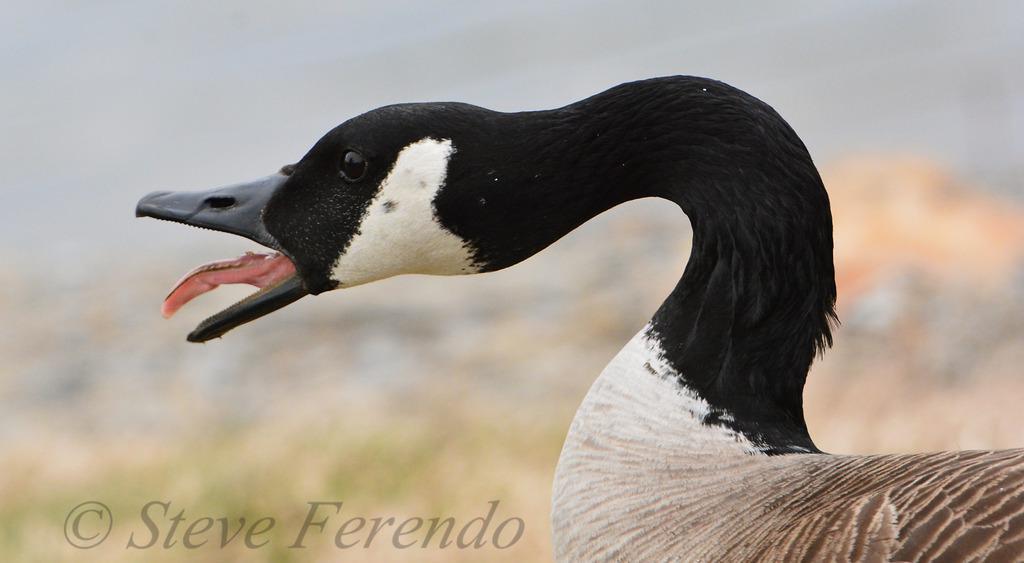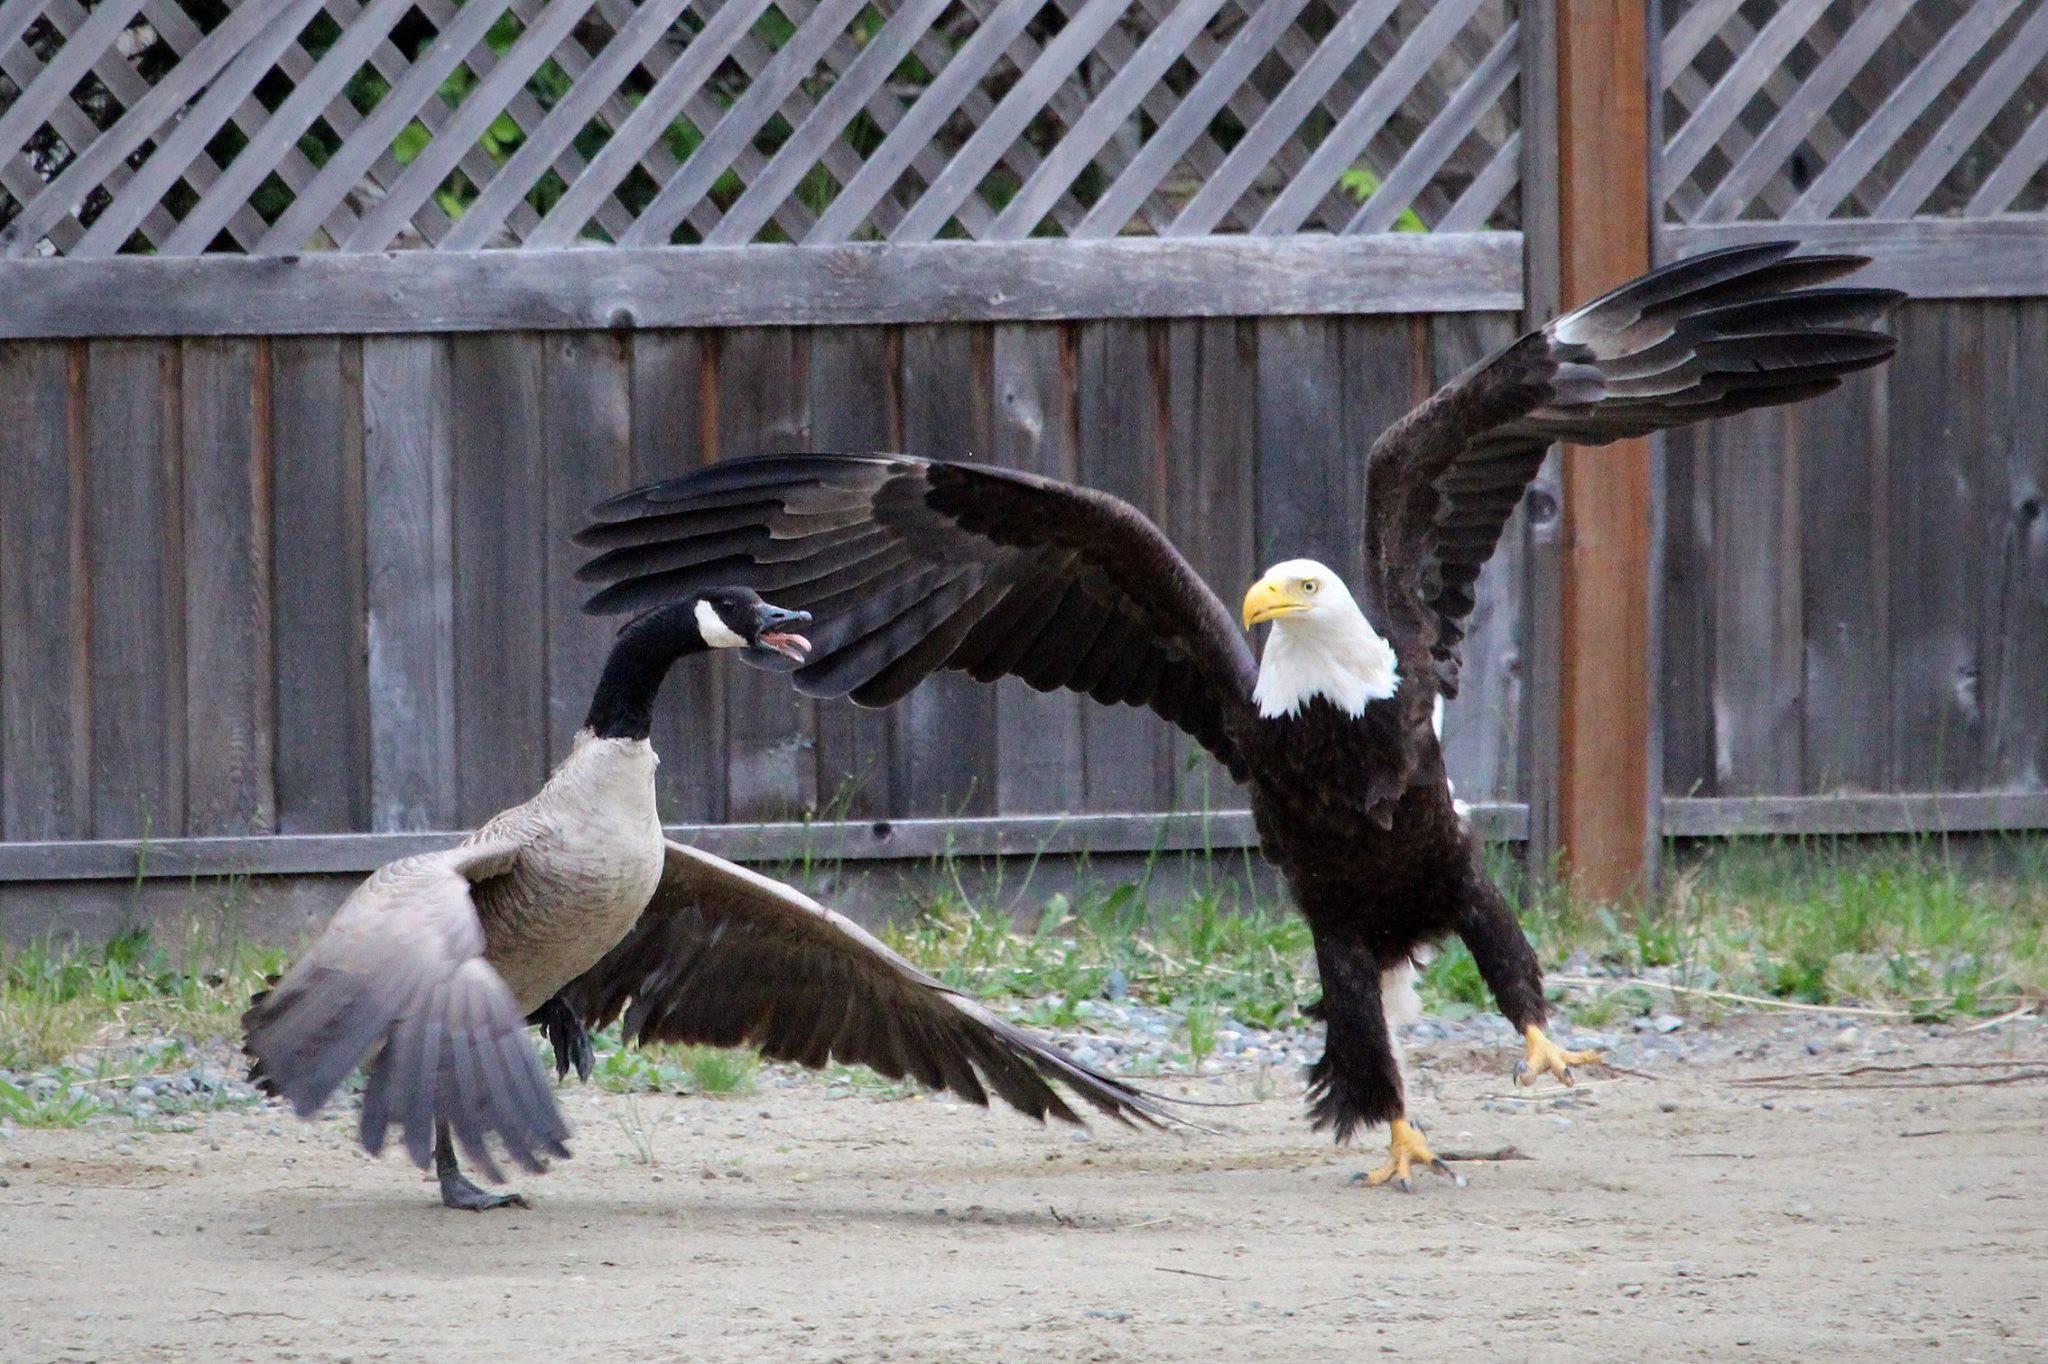The first image is the image on the left, the second image is the image on the right. For the images displayed, is the sentence "There is one eagle" factually correct? Answer yes or no. Yes. 